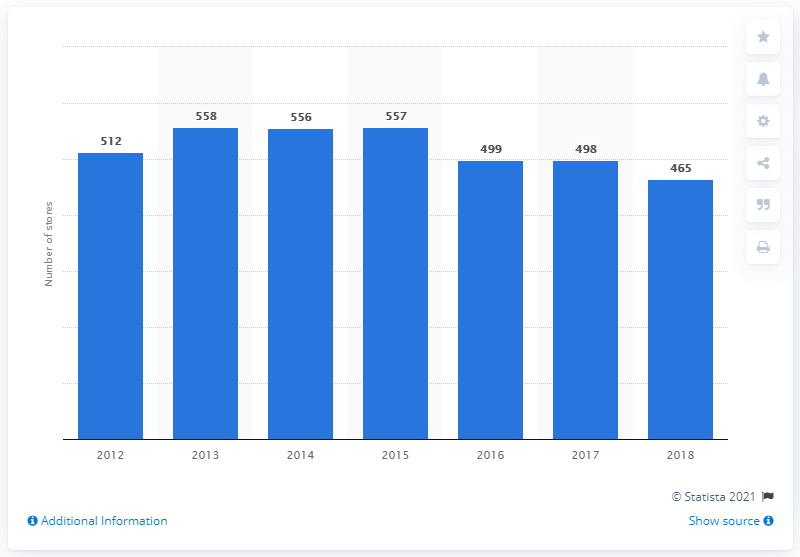List a handful of essential elements in this visual. In 2018, Walmart had a total of 465 stores in Brazil. 